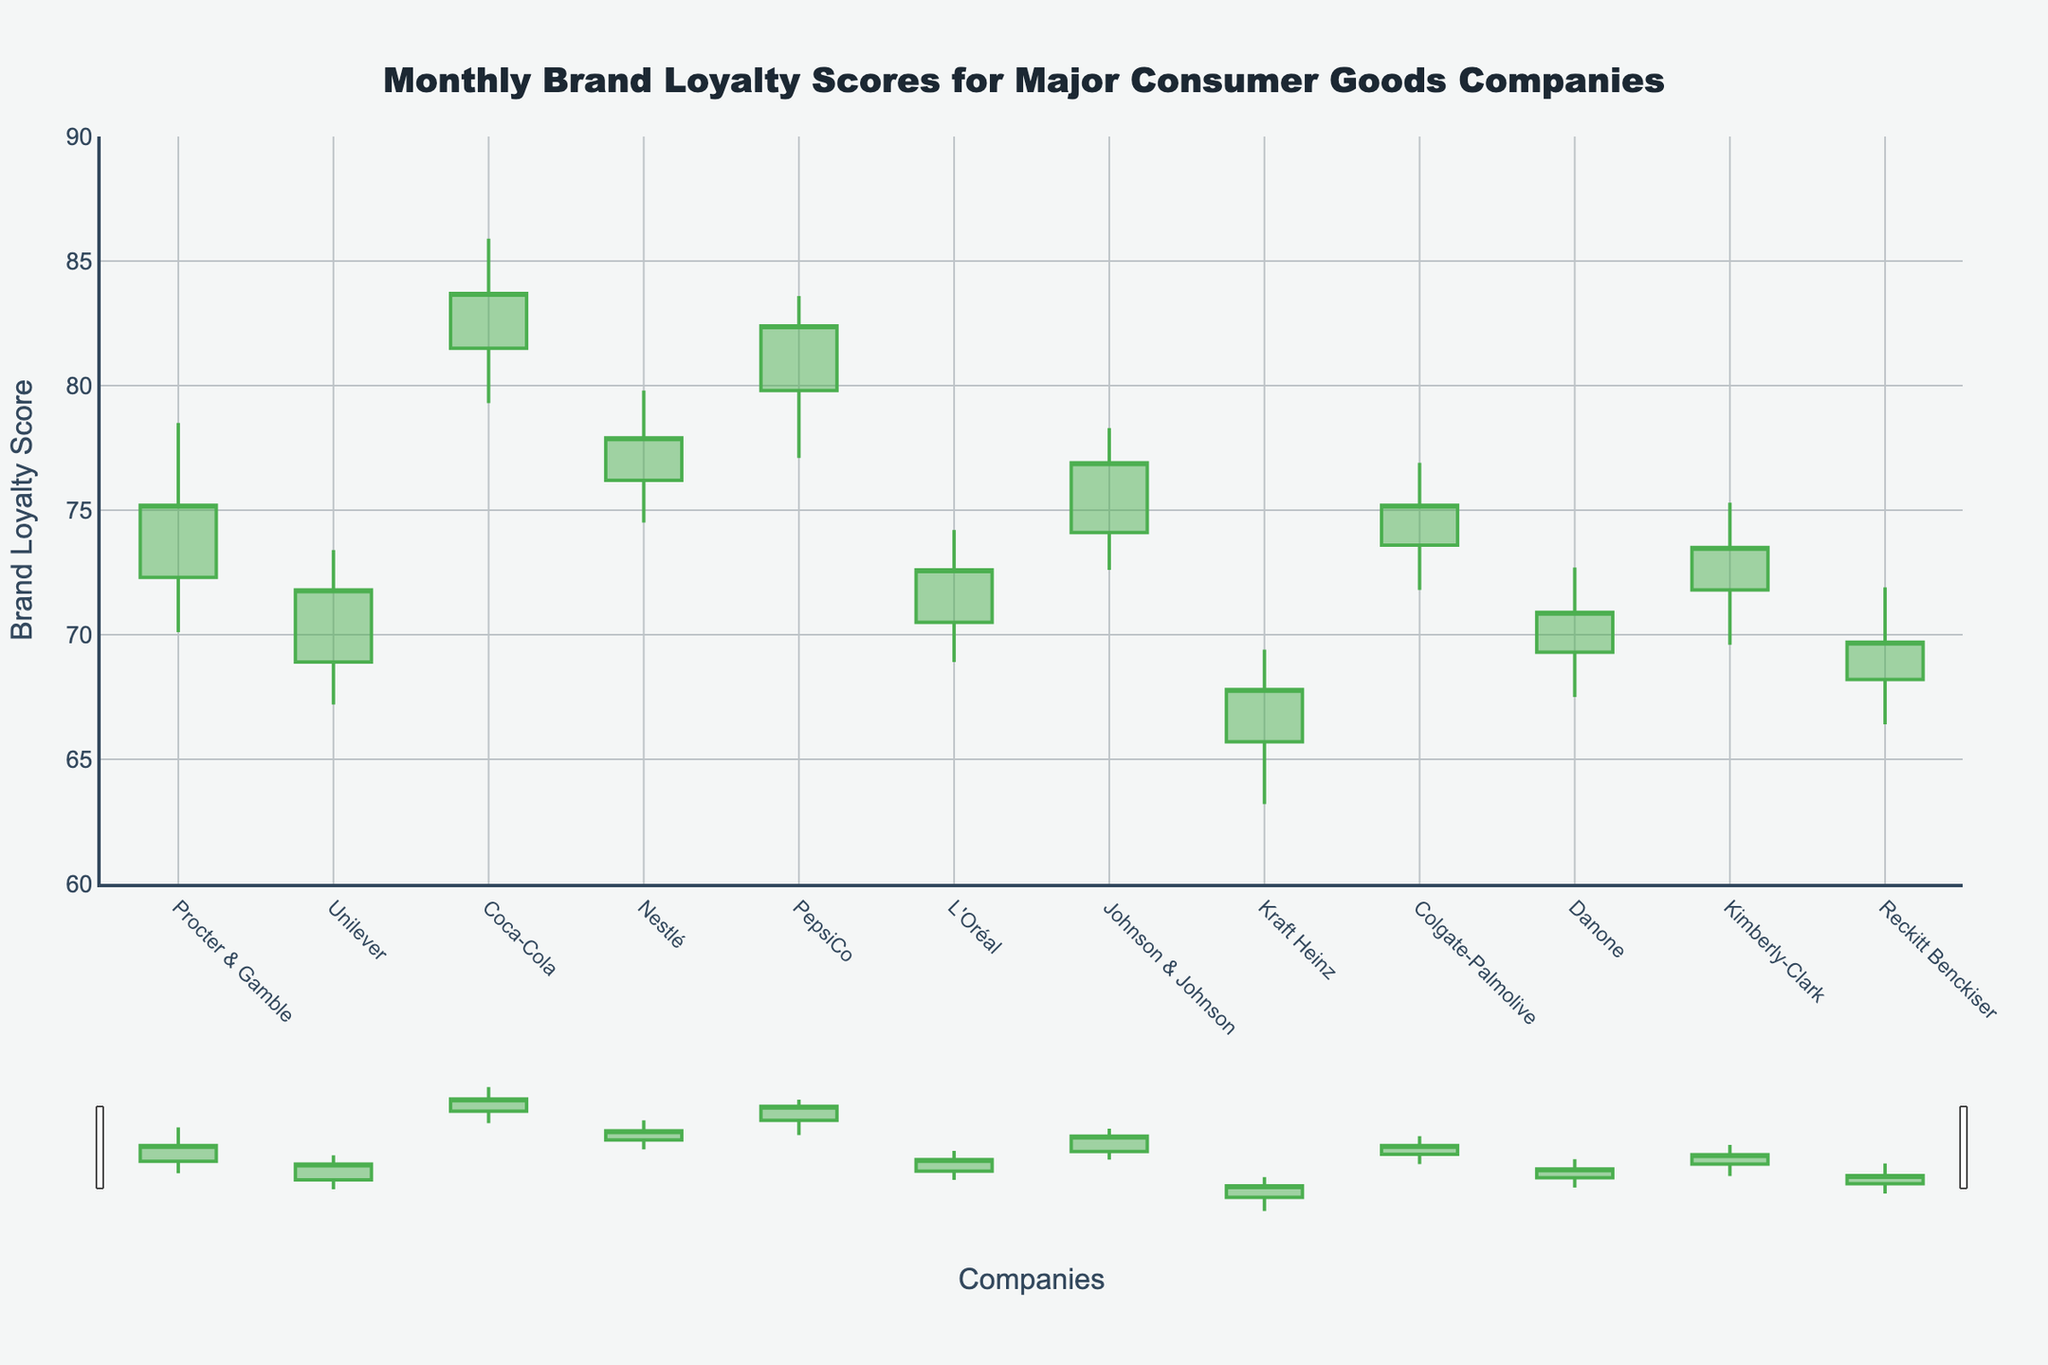What's the title of the chart? The title of the chart is located at the top and is large and bold, written in dark color. It is easy to spot as it provides the primary context.
Answer: Monthly Brand Loyalty Scores for Major Consumer Goods Companies What is the brand loyalty score range shown on the y-axis? The y-axis displays the range of brand loyalty scores, which can be identified by the numbers marked along the axis.
Answer: 60 to 90 Which company had the highest brand loyalty score in any month? Observing the highest points in the chart, the company with the tallest candlestick height indicates the highest score.
Answer: Coca-Cola Which company had the lowest opening score? The opening scores are represented by the lower end of each candlestick’s body. The company with the lowest starting point is identified here.
Answer: Kraft Heinz What is the difference between the highest and lowest brand loyalty score for PepsiCo? The highest and lowest points on the candlestick for PepsiCo are identified, and their numerical difference is calculated.
Answer: 6.5 Comparing Procter & Gamble and Johnson & Johnson, which had a higher closing score? Look at the closing scores represented by the top edge of the candlesticks' body for both companies to determine which is higher.
Answer: Johnson & Johnson Which company exhibited the most stability in their brand loyalty score? Most stability would mean the smallest difference between the high and low scores shown by the candlestick's wick length.
Answer: Nestlé Which company had a lower closing score compared to their opening score? Companies with a red candlestick indicate a lower closing score compared to their opening score since the color represents decreasing values.
Answer: Danone Identify the company with the largest increase in brand loyalty score from opening to closing within a month. The largest green candlestick indicates the highest increase in score from opening to closing.
Answer: Unilever 